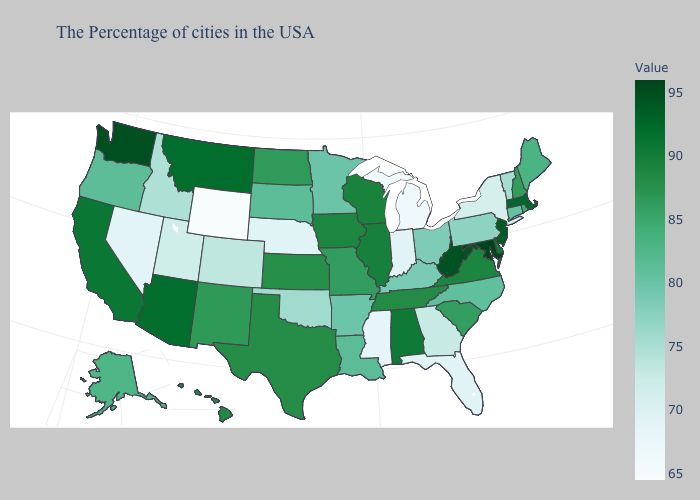Which states have the lowest value in the USA?
Answer briefly. Wyoming. Which states have the lowest value in the Northeast?
Keep it brief. New York. Does Massachusetts have the lowest value in the Northeast?
Quick response, please. No. Does the map have missing data?
Be succinct. No. Does New York have the lowest value in the Northeast?
Concise answer only. Yes. 